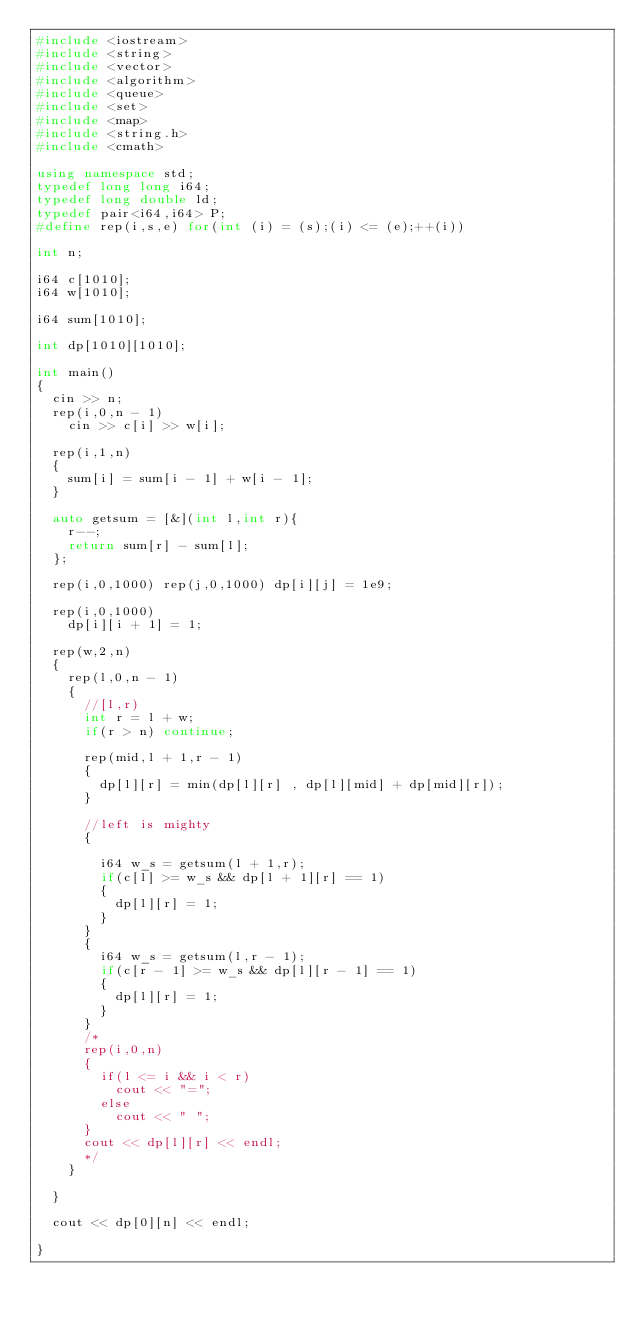Convert code to text. <code><loc_0><loc_0><loc_500><loc_500><_C++_>#include <iostream>
#include <string>
#include <vector>
#include <algorithm>
#include <queue>
#include <set>
#include <map>
#include <string.h>
#include <cmath>

using namespace std;
typedef long long i64;
typedef long double ld;
typedef pair<i64,i64> P;
#define rep(i,s,e) for(int (i) = (s);(i) <= (e);++(i))

int n;

i64 c[1010];
i64 w[1010];

i64 sum[1010];

int dp[1010][1010];

int main()
{
	cin >> n;
	rep(i,0,n - 1)
		cin >> c[i] >> w[i];

	rep(i,1,n)
	{
		sum[i] = sum[i - 1] + w[i - 1];
	}

	auto getsum = [&](int l,int r){
		r--;
		return sum[r] - sum[l];
	};

	rep(i,0,1000) rep(j,0,1000) dp[i][j] = 1e9;

	rep(i,0,1000)
		dp[i][i + 1] = 1;
	
	rep(w,2,n)
	{
		rep(l,0,n - 1)
		{
			//[l,r)
			int r = l + w;
			if(r > n) continue;

			rep(mid,l + 1,r - 1)
			{
				dp[l][r] = min(dp[l][r] , dp[l][mid] + dp[mid][r]);
			}

			//left is mighty
			{

				i64 w_s = getsum(l + 1,r);
				if(c[l] >= w_s && dp[l + 1][r] == 1)
				{
					dp[l][r] = 1;
				}
			}
			{
				i64 w_s = getsum(l,r - 1);
				if(c[r - 1] >= w_s && dp[l][r - 1] == 1)
				{
					dp[l][r] = 1;
				}
			}
			/*
			rep(i,0,n)
			{
				if(l <= i && i < r)
					cout << "=";
				else
					cout << " ";
			}
			cout << dp[l][r] << endl;
			*/
		}

	}

	cout << dp[0][n] << endl;

}

</code> 